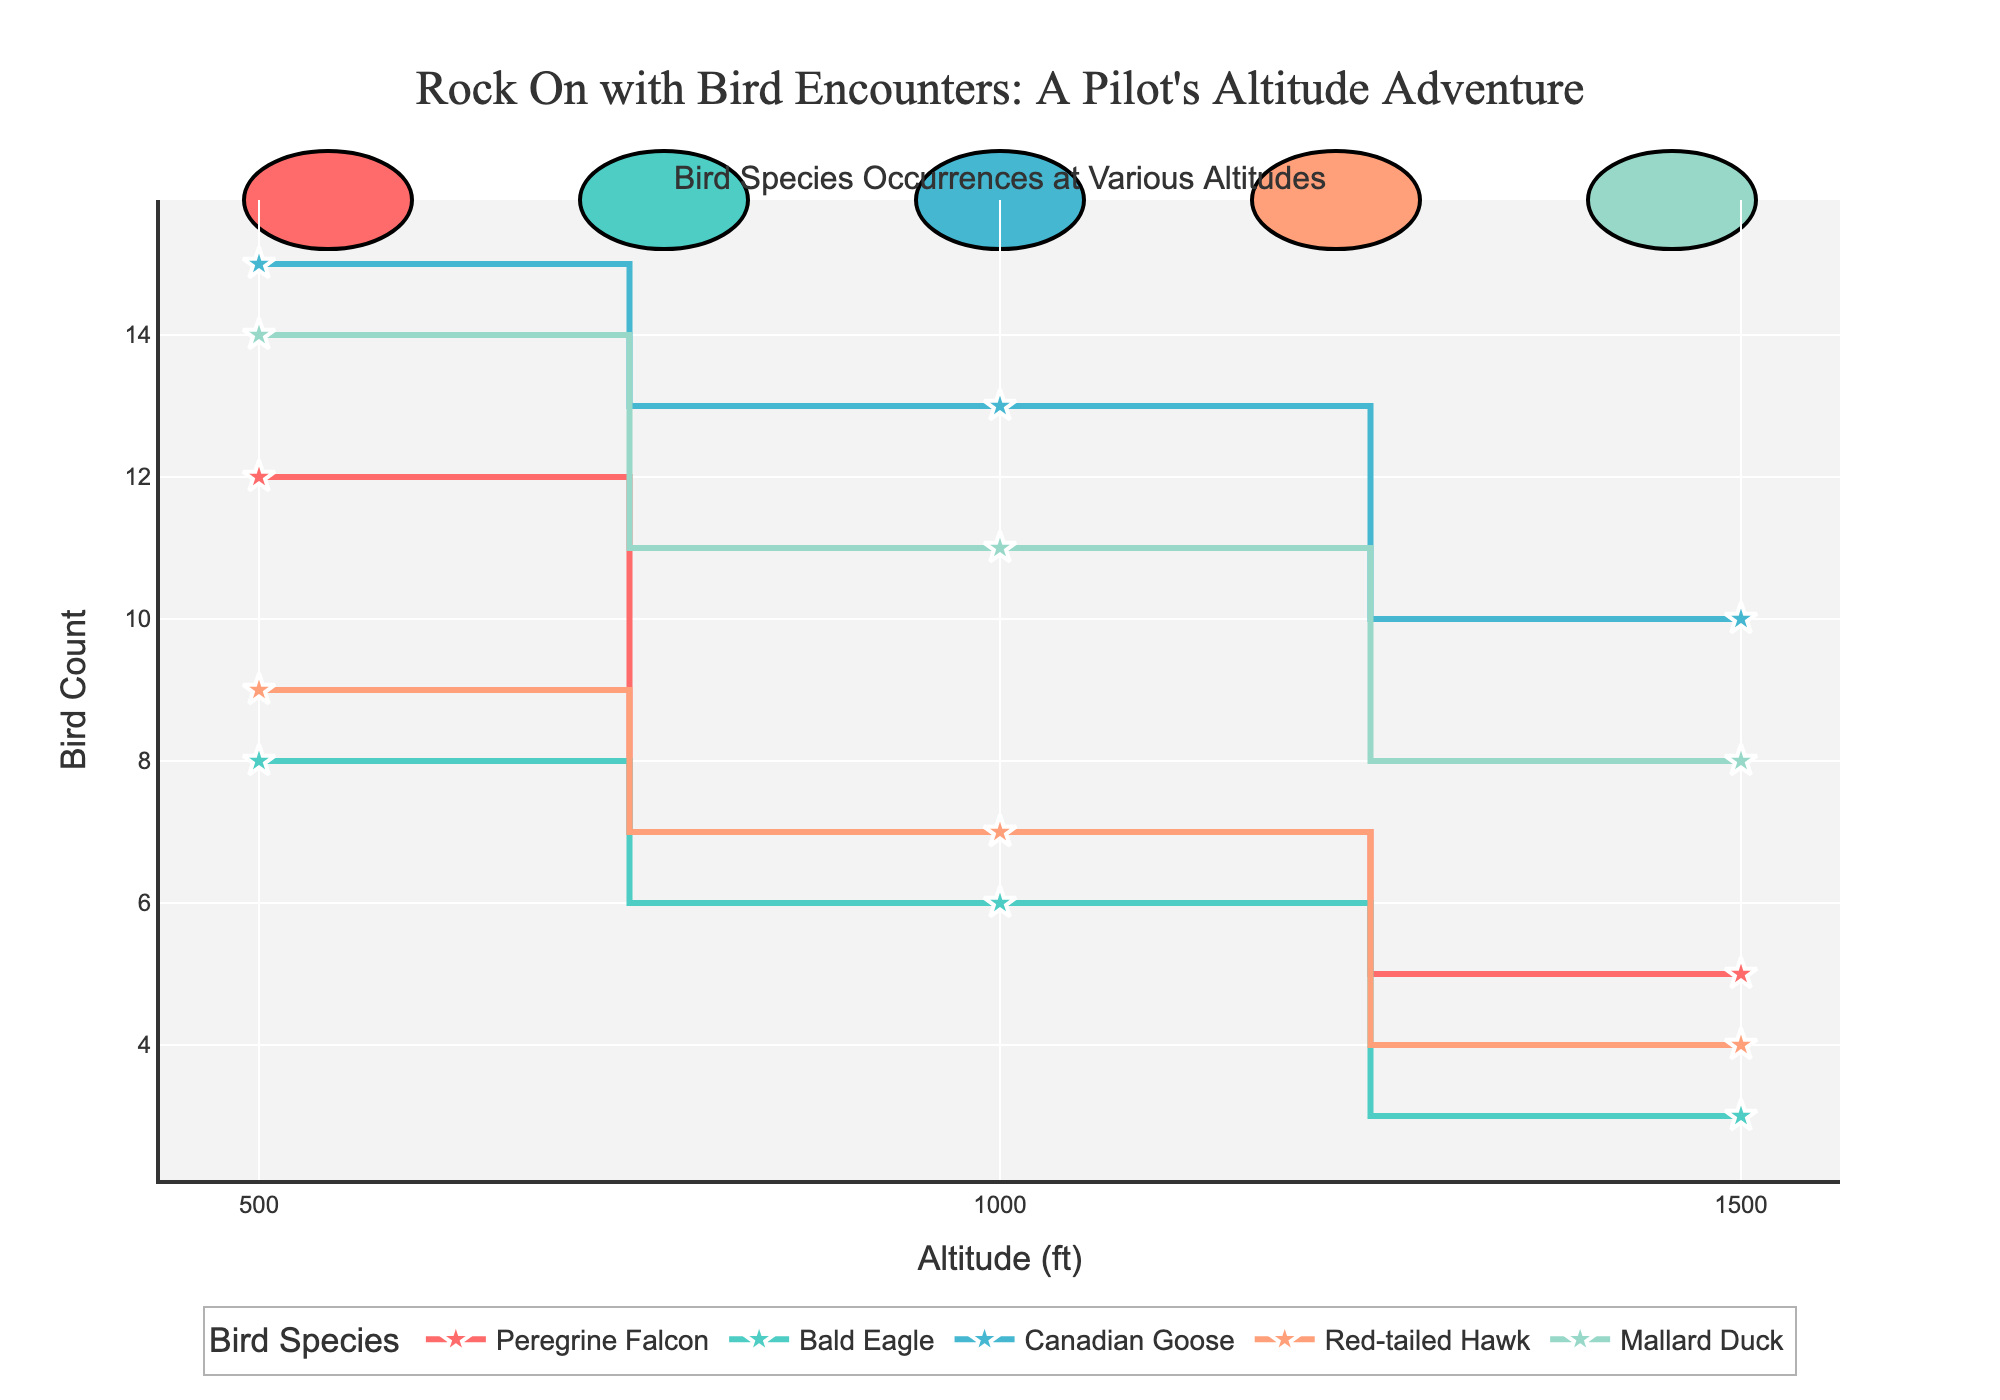How many bird species are included in the plot? There are different colored lines for each species and each line corresponds to a different bird species. By counting these lines, we can see there are five unique species included in the plot.
Answer: Five Which bird species has the highest count at the 0-500 ft altitude range? By looking at the y-axis values for the 0-500 ft range across all species, we can see that Canadian Goose has the highest count since it reaches the highest point on the y-axis in this altitude range.
Answer: Canadian Goose What is the total count of Bald Eagle sightings across all altitudes? Add the counts of Bald Eagle sightings for each altitude range: 8 (0-500 ft) + 6 (500-1000 ft) + 3 (1000-1500 ft). The total count is 17.
Answer: 17 Which species show the steepest drop in occurrences from 0-500 ft to 500-1000 ft? To determine this, we need to look at the lines' slopes between these two altitude ranges. The steepest drop is observed for the Mallard Duck, where the count drops from 14 to 11.
Answer: Mallard Duck What is the sum of occurrences for the Peregrine Falcon at altitudes above 500 ft? Add the counts for the Peregrine Falcon from 500-1000 ft (7) and 1000-1500 ft (5). The total is 12 occurrences.
Answer: 12 Which species have more than 10 occurrences in any altitude range? Checking the y-axis values, the species that have more than 10 occurrences in at least one altitude range are: Peregrine Falcon (0-500 ft), Canadian Goose (0-500 ft and 500-1000 ft), and Mallard Duck (0-500 ft and 500-1000 ft).
Answer: Peregrine Falcon, Canadian Goose, Mallard Duck Are there any bird species that have a consistent number of occurrences across all altitudes? A consistent number of occurrences would mean the y-values (counts) are the same across all altitudes for that species. No species in the plot shows the same count across all three altitude ranges.
Answer: No At which altitude range is the occurrence of the Red-tailed Hawk the highest? By referring to the y-axis counts for the Red-tailed Hawk, the highest occurrence is at 0-500 ft, where the count is 9.
Answer: 0-500 ft Which bird species shows the least occurrences overall? Sum the occurrences for each species across all altitude ranges. The species with the smallest total sum is the Bald Eagle with a total of 17.
Answer: Bald Eagle 